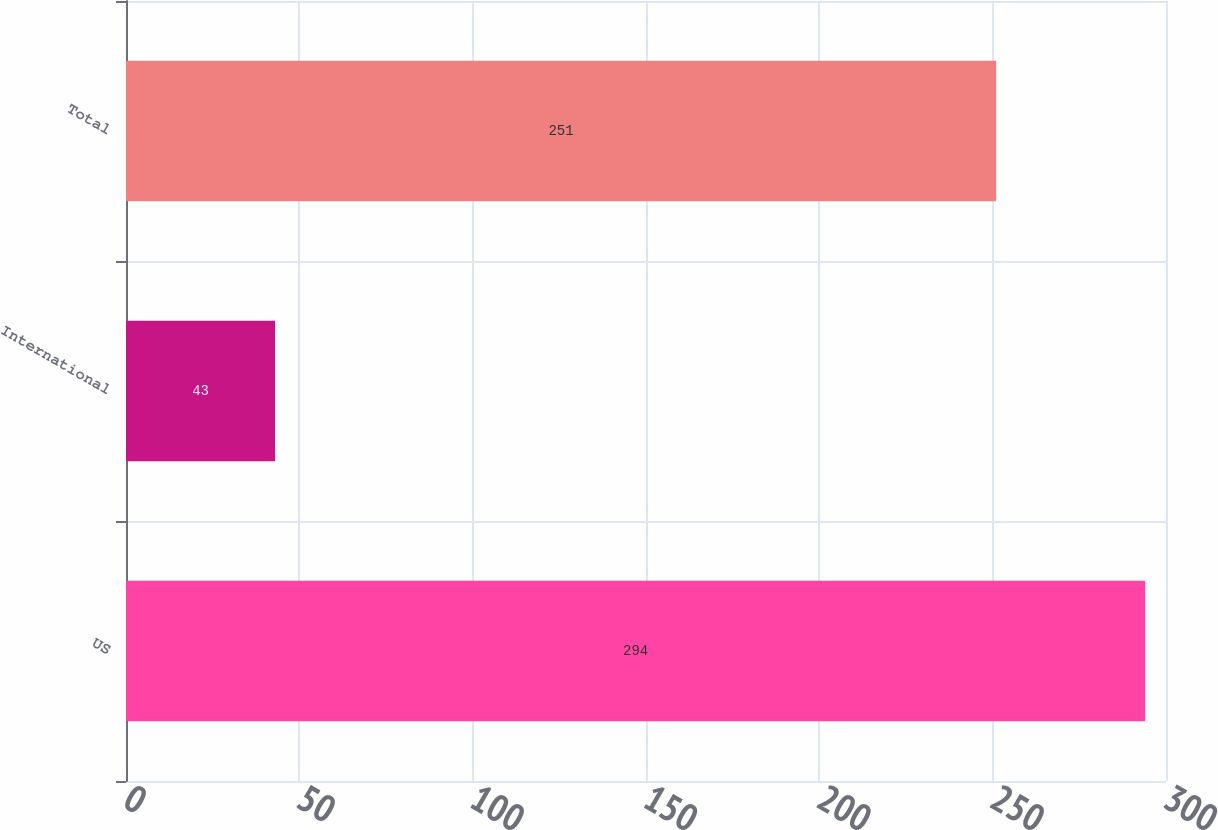Convert chart. <chart><loc_0><loc_0><loc_500><loc_500><bar_chart><fcel>US<fcel>International<fcel>Total<nl><fcel>294<fcel>43<fcel>251<nl></chart> 